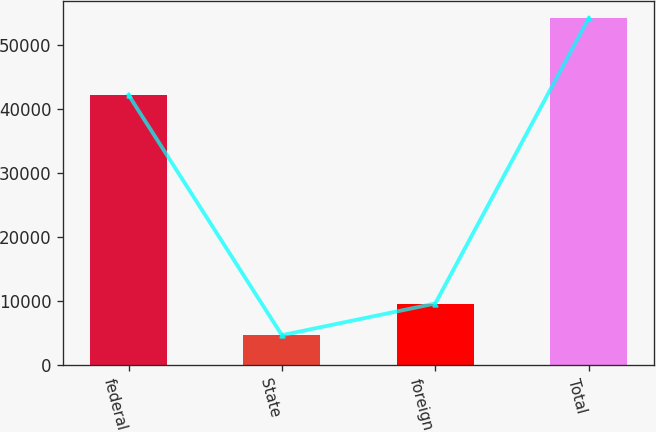Convert chart to OTSL. <chart><loc_0><loc_0><loc_500><loc_500><bar_chart><fcel>federal<fcel>State<fcel>foreign<fcel>Total<nl><fcel>42146<fcel>4706<fcel>9645.2<fcel>54098<nl></chart> 